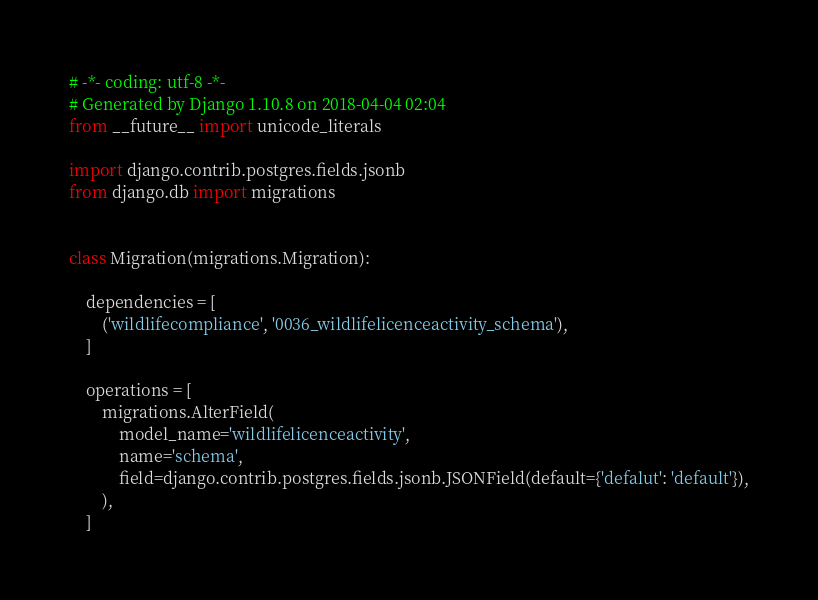<code> <loc_0><loc_0><loc_500><loc_500><_Python_># -*- coding: utf-8 -*-
# Generated by Django 1.10.8 on 2018-04-04 02:04
from __future__ import unicode_literals

import django.contrib.postgres.fields.jsonb
from django.db import migrations


class Migration(migrations.Migration):

    dependencies = [
        ('wildlifecompliance', '0036_wildlifelicenceactivity_schema'),
    ]

    operations = [
        migrations.AlterField(
            model_name='wildlifelicenceactivity',
            name='schema',
            field=django.contrib.postgres.fields.jsonb.JSONField(default={'defalut': 'default'}),
        ),
    ]
</code> 